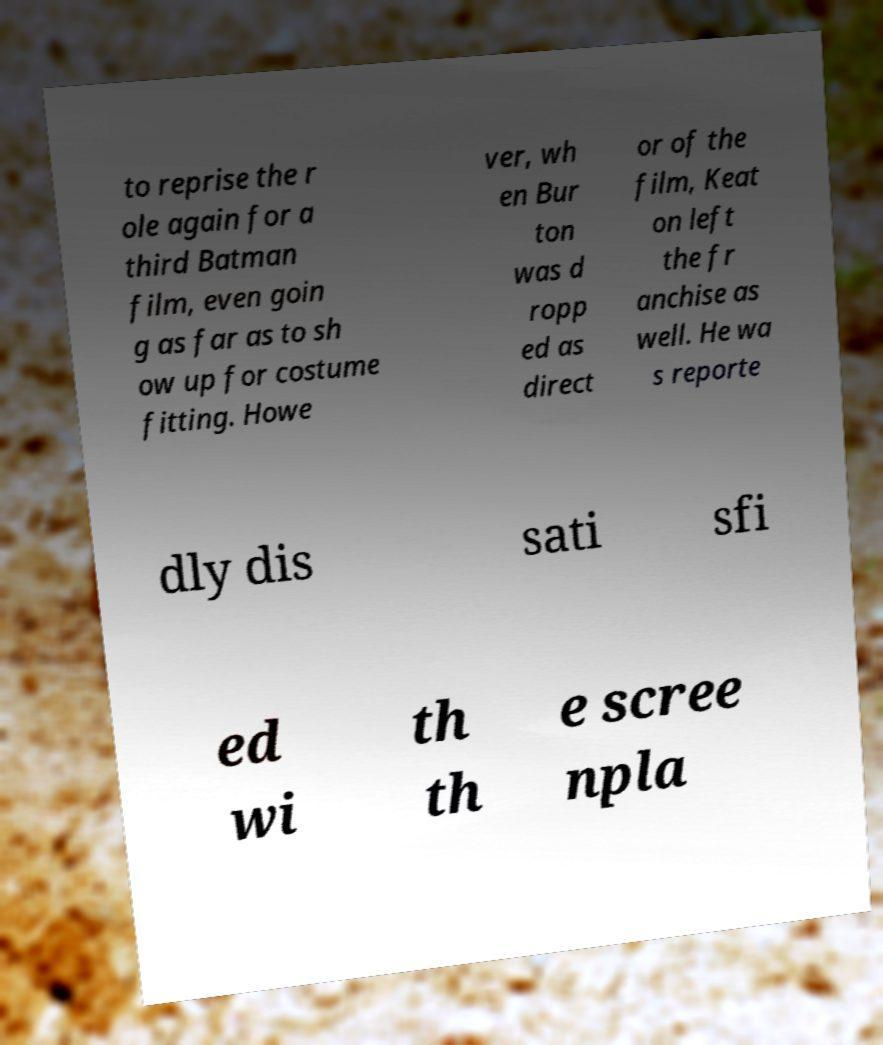Could you extract and type out the text from this image? to reprise the r ole again for a third Batman film, even goin g as far as to sh ow up for costume fitting. Howe ver, wh en Bur ton was d ropp ed as direct or of the film, Keat on left the fr anchise as well. He wa s reporte dly dis sati sfi ed wi th th e scree npla 